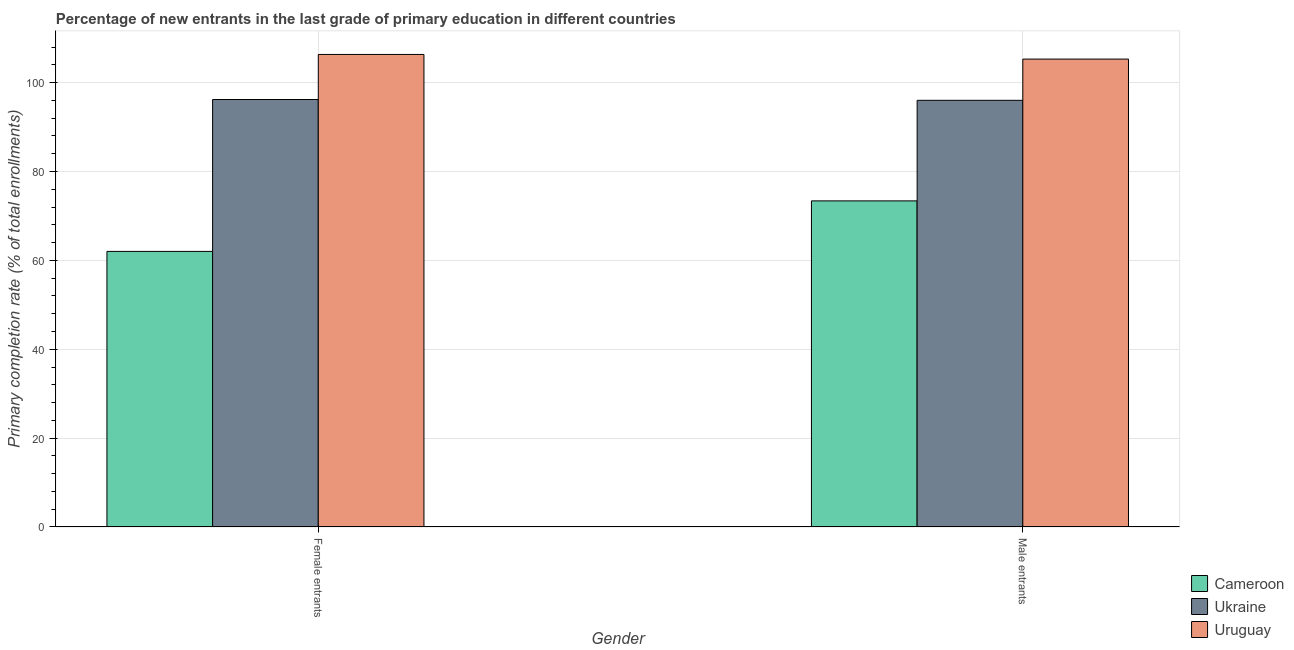How many different coloured bars are there?
Keep it short and to the point. 3. What is the label of the 2nd group of bars from the left?
Offer a very short reply. Male entrants. What is the primary completion rate of female entrants in Ukraine?
Provide a succinct answer. 96.21. Across all countries, what is the maximum primary completion rate of male entrants?
Your response must be concise. 105.3. Across all countries, what is the minimum primary completion rate of male entrants?
Provide a short and direct response. 73.39. In which country was the primary completion rate of male entrants maximum?
Provide a succinct answer. Uruguay. In which country was the primary completion rate of male entrants minimum?
Your answer should be very brief. Cameroon. What is the total primary completion rate of male entrants in the graph?
Your answer should be very brief. 274.72. What is the difference between the primary completion rate of female entrants in Uruguay and that in Ukraine?
Offer a terse response. 10.14. What is the difference between the primary completion rate of female entrants in Ukraine and the primary completion rate of male entrants in Uruguay?
Ensure brevity in your answer.  -9.1. What is the average primary completion rate of male entrants per country?
Offer a terse response. 91.57. What is the difference between the primary completion rate of male entrants and primary completion rate of female entrants in Ukraine?
Offer a terse response. -0.18. In how many countries, is the primary completion rate of male entrants greater than 8 %?
Give a very brief answer. 3. What is the ratio of the primary completion rate of female entrants in Cameroon to that in Uruguay?
Keep it short and to the point. 0.58. Is the primary completion rate of female entrants in Ukraine less than that in Uruguay?
Give a very brief answer. Yes. What does the 3rd bar from the left in Female entrants represents?
Give a very brief answer. Uruguay. What does the 3rd bar from the right in Male entrants represents?
Give a very brief answer. Cameroon. Are all the bars in the graph horizontal?
Ensure brevity in your answer.  No. Are the values on the major ticks of Y-axis written in scientific E-notation?
Your answer should be very brief. No. How are the legend labels stacked?
Provide a short and direct response. Vertical. What is the title of the graph?
Your answer should be compact. Percentage of new entrants in the last grade of primary education in different countries. Does "Namibia" appear as one of the legend labels in the graph?
Offer a terse response. No. What is the label or title of the Y-axis?
Give a very brief answer. Primary completion rate (% of total enrollments). What is the Primary completion rate (% of total enrollments) in Cameroon in Female entrants?
Keep it short and to the point. 62.03. What is the Primary completion rate (% of total enrollments) of Ukraine in Female entrants?
Offer a terse response. 96.21. What is the Primary completion rate (% of total enrollments) in Uruguay in Female entrants?
Keep it short and to the point. 106.35. What is the Primary completion rate (% of total enrollments) of Cameroon in Male entrants?
Keep it short and to the point. 73.39. What is the Primary completion rate (% of total enrollments) in Ukraine in Male entrants?
Provide a succinct answer. 96.03. What is the Primary completion rate (% of total enrollments) of Uruguay in Male entrants?
Provide a short and direct response. 105.3. Across all Gender, what is the maximum Primary completion rate (% of total enrollments) in Cameroon?
Make the answer very short. 73.39. Across all Gender, what is the maximum Primary completion rate (% of total enrollments) in Ukraine?
Keep it short and to the point. 96.21. Across all Gender, what is the maximum Primary completion rate (% of total enrollments) of Uruguay?
Your answer should be very brief. 106.35. Across all Gender, what is the minimum Primary completion rate (% of total enrollments) of Cameroon?
Offer a terse response. 62.03. Across all Gender, what is the minimum Primary completion rate (% of total enrollments) of Ukraine?
Offer a very short reply. 96.03. Across all Gender, what is the minimum Primary completion rate (% of total enrollments) of Uruguay?
Offer a terse response. 105.3. What is the total Primary completion rate (% of total enrollments) of Cameroon in the graph?
Offer a very short reply. 135.42. What is the total Primary completion rate (% of total enrollments) in Ukraine in the graph?
Ensure brevity in your answer.  192.23. What is the total Primary completion rate (% of total enrollments) in Uruguay in the graph?
Your response must be concise. 211.65. What is the difference between the Primary completion rate (% of total enrollments) in Cameroon in Female entrants and that in Male entrants?
Keep it short and to the point. -11.37. What is the difference between the Primary completion rate (% of total enrollments) in Ukraine in Female entrants and that in Male entrants?
Offer a terse response. 0.18. What is the difference between the Primary completion rate (% of total enrollments) in Uruguay in Female entrants and that in Male entrants?
Make the answer very short. 1.04. What is the difference between the Primary completion rate (% of total enrollments) of Cameroon in Female entrants and the Primary completion rate (% of total enrollments) of Ukraine in Male entrants?
Offer a very short reply. -34. What is the difference between the Primary completion rate (% of total enrollments) of Cameroon in Female entrants and the Primary completion rate (% of total enrollments) of Uruguay in Male entrants?
Provide a succinct answer. -43.28. What is the difference between the Primary completion rate (% of total enrollments) of Ukraine in Female entrants and the Primary completion rate (% of total enrollments) of Uruguay in Male entrants?
Give a very brief answer. -9.1. What is the average Primary completion rate (% of total enrollments) of Cameroon per Gender?
Provide a short and direct response. 67.71. What is the average Primary completion rate (% of total enrollments) in Ukraine per Gender?
Your answer should be compact. 96.12. What is the average Primary completion rate (% of total enrollments) of Uruguay per Gender?
Ensure brevity in your answer.  105.83. What is the difference between the Primary completion rate (% of total enrollments) of Cameroon and Primary completion rate (% of total enrollments) of Ukraine in Female entrants?
Give a very brief answer. -34.18. What is the difference between the Primary completion rate (% of total enrollments) of Cameroon and Primary completion rate (% of total enrollments) of Uruguay in Female entrants?
Offer a terse response. -44.32. What is the difference between the Primary completion rate (% of total enrollments) in Ukraine and Primary completion rate (% of total enrollments) in Uruguay in Female entrants?
Make the answer very short. -10.14. What is the difference between the Primary completion rate (% of total enrollments) in Cameroon and Primary completion rate (% of total enrollments) in Ukraine in Male entrants?
Ensure brevity in your answer.  -22.63. What is the difference between the Primary completion rate (% of total enrollments) of Cameroon and Primary completion rate (% of total enrollments) of Uruguay in Male entrants?
Offer a terse response. -31.91. What is the difference between the Primary completion rate (% of total enrollments) of Ukraine and Primary completion rate (% of total enrollments) of Uruguay in Male entrants?
Provide a succinct answer. -9.28. What is the ratio of the Primary completion rate (% of total enrollments) of Cameroon in Female entrants to that in Male entrants?
Your answer should be very brief. 0.85. What is the ratio of the Primary completion rate (% of total enrollments) of Uruguay in Female entrants to that in Male entrants?
Keep it short and to the point. 1.01. What is the difference between the highest and the second highest Primary completion rate (% of total enrollments) of Cameroon?
Offer a terse response. 11.37. What is the difference between the highest and the second highest Primary completion rate (% of total enrollments) of Ukraine?
Your answer should be very brief. 0.18. What is the difference between the highest and the second highest Primary completion rate (% of total enrollments) of Uruguay?
Keep it short and to the point. 1.04. What is the difference between the highest and the lowest Primary completion rate (% of total enrollments) of Cameroon?
Keep it short and to the point. 11.37. What is the difference between the highest and the lowest Primary completion rate (% of total enrollments) of Ukraine?
Keep it short and to the point. 0.18. What is the difference between the highest and the lowest Primary completion rate (% of total enrollments) in Uruguay?
Your response must be concise. 1.04. 